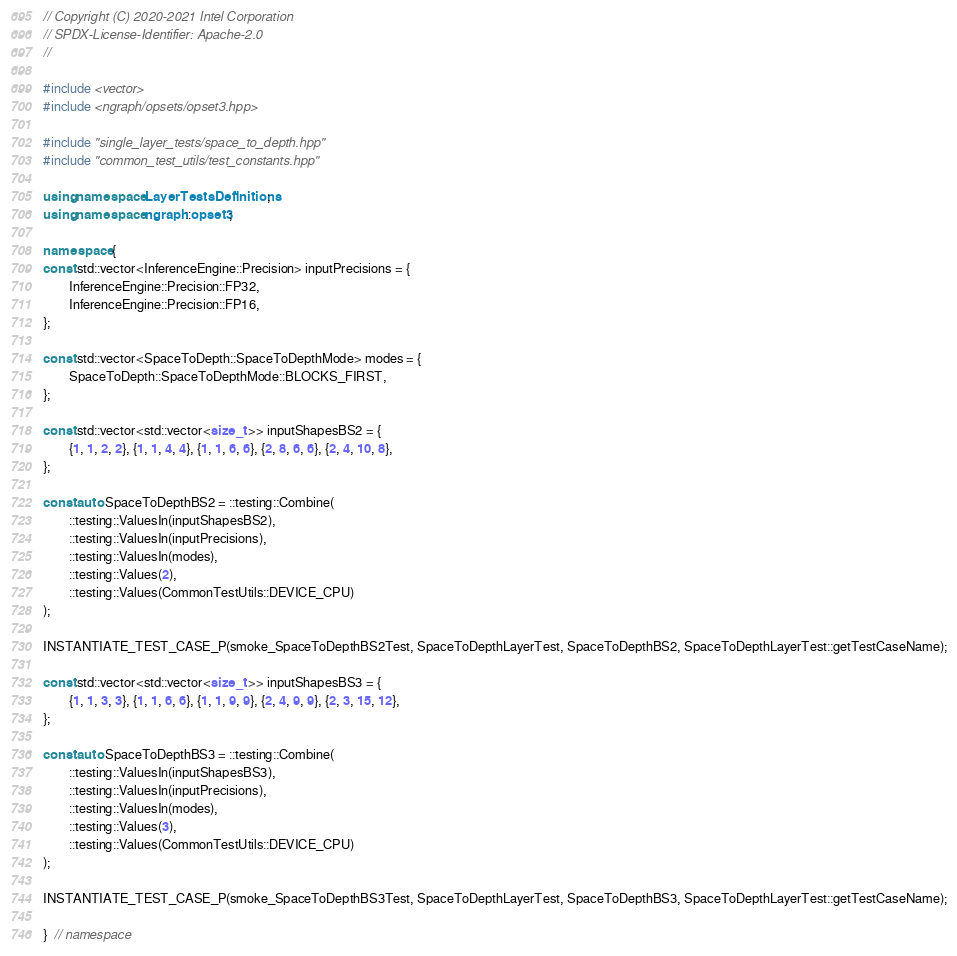<code> <loc_0><loc_0><loc_500><loc_500><_C++_>// Copyright (C) 2020-2021 Intel Corporation
// SPDX-License-Identifier: Apache-2.0
//

#include <vector>
#include <ngraph/opsets/opset3.hpp>

#include "single_layer_tests/space_to_depth.hpp"
#include "common_test_utils/test_constants.hpp"

using namespace LayerTestsDefinitions;
using namespace ngraph::opset3;

namespace {
const std::vector<InferenceEngine::Precision> inputPrecisions = {
        InferenceEngine::Precision::FP32,
        InferenceEngine::Precision::FP16,
};

const std::vector<SpaceToDepth::SpaceToDepthMode> modes = {
        SpaceToDepth::SpaceToDepthMode::BLOCKS_FIRST,
};

const std::vector<std::vector<size_t >> inputShapesBS2 = {
        {1, 1, 2, 2}, {1, 1, 4, 4}, {1, 1, 6, 6}, {2, 8, 6, 6}, {2, 4, 10, 8},
};

const auto SpaceToDepthBS2 = ::testing::Combine(
        ::testing::ValuesIn(inputShapesBS2),
        ::testing::ValuesIn(inputPrecisions),
        ::testing::ValuesIn(modes),
        ::testing::Values(2),
        ::testing::Values(CommonTestUtils::DEVICE_CPU)
);

INSTANTIATE_TEST_CASE_P(smoke_SpaceToDepthBS2Test, SpaceToDepthLayerTest, SpaceToDepthBS2, SpaceToDepthLayerTest::getTestCaseName);

const std::vector<std::vector<size_t >> inputShapesBS3 = {
        {1, 1, 3, 3}, {1, 1, 6, 6}, {1, 1, 9, 9}, {2, 4, 9, 9}, {2, 3, 15, 12},
};

const auto SpaceToDepthBS3 = ::testing::Combine(
        ::testing::ValuesIn(inputShapesBS3),
        ::testing::ValuesIn(inputPrecisions),
        ::testing::ValuesIn(modes),
        ::testing::Values(3),
        ::testing::Values(CommonTestUtils::DEVICE_CPU)
);

INSTANTIATE_TEST_CASE_P(smoke_SpaceToDepthBS3Test, SpaceToDepthLayerTest, SpaceToDepthBS3, SpaceToDepthLayerTest::getTestCaseName);

}  // namespace</code> 